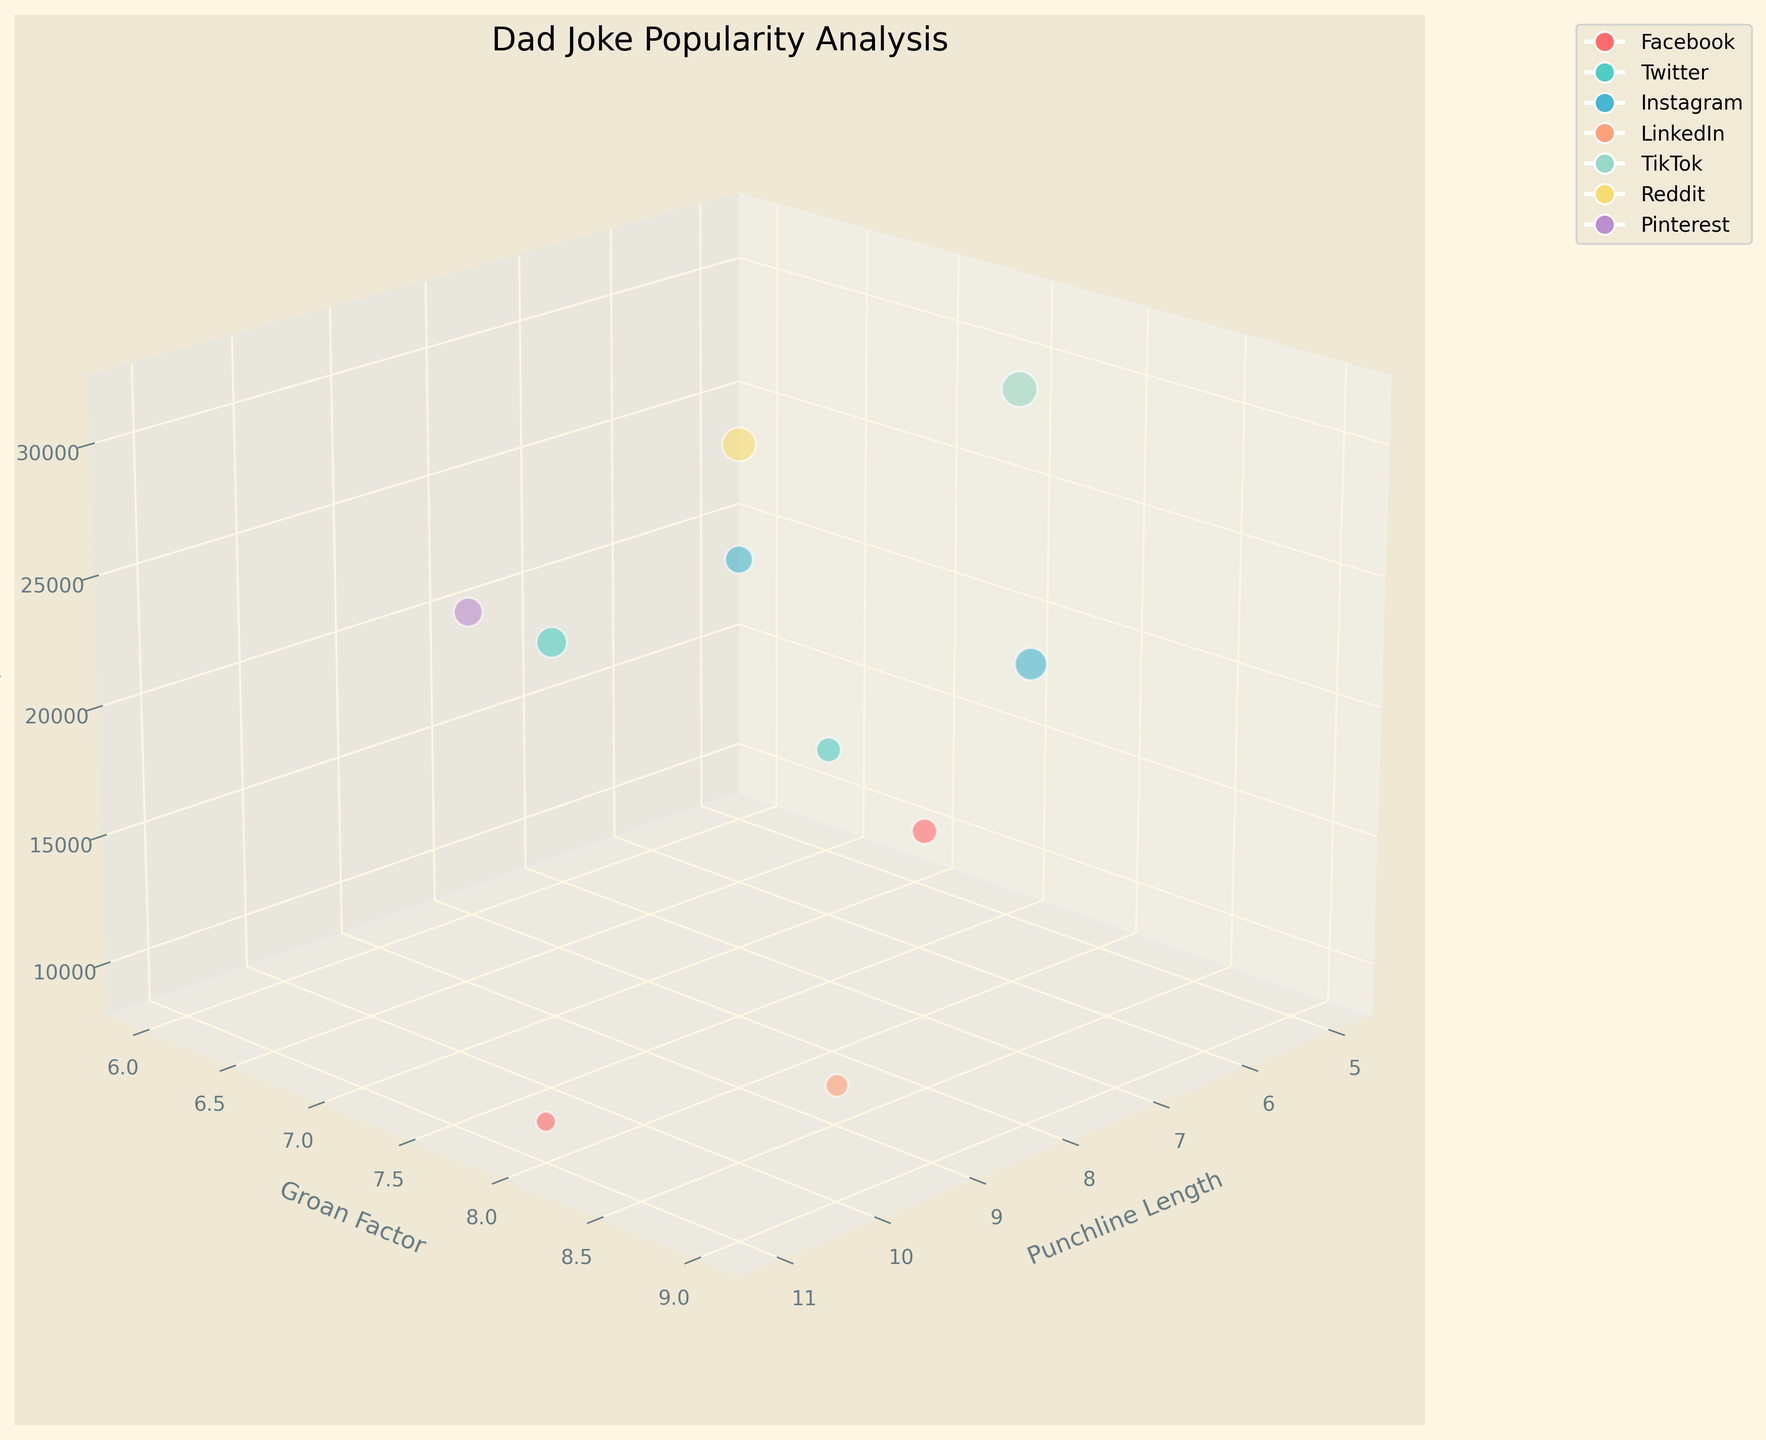How many social media platforms are represented in the chart? We start by examining the legend or checking the number of different colors in the plot. Each color represents a unique platform. By counting them, we see there are six platforms: Facebook, Twitter, Instagram, LinkedIn, TikTok, and Reddit.
Answer: 6 Which axis represents the punchline length of the jokes? By looking at the axis labels, we can identify which axis corresponds to punchline length. The label of the x-axis reads "Punchline Length."
Answer: x-axis Which joke has received the highest number of shares? We look for the bubble with the largest size in the chart since bubble size is proportional to the number of shares. By checking the legends and data points, we find that the joke "How do you organize a space party? You planet!" from TikTok has the highest number of shares at 31,000.
Answer: “How do you organize a space party? You planet!” Which platform has the joke with the longest punchline length? We identify the joke with the highest x-axis (punchline length) value and note its color. The longest punchline is 11, which matches the color representing Facebook.
Answer: Facebook What is the average groan factor of the jokes across all platforms? The groan factors are 8, 7, 6, 9, 8, 7, 6, 8, 7, and 9. Adding these together gives 75. Dividing by the number of jokes (10) results in an average of 7.5
Answer: 7.5 Which joke on LinkedIn received the lowest number of shares? By looking at the data for LinkedIn jokes, we see there is only one represented. It is the joke "Why did the scarecrow win an award?" with 12,300 shares, which is consequently the lowest.
Answer: "Why did the scarecrow win an award?" Is there a relationship between groan factor and the number of shares? Analyzing the z-axis for shares and the y-axis for groan factor, we observe that jokes with higher groan factors like 8 or 9 tend to also have higher shares. However, this is not always the case, indicating a weak positive trend.
Answer: Weak positive trend Which jokes have the same groan factor but are from different platforms? We compare jokes with identical y-axis (groan factor) values. For example, both "What do you call a bear with no teeth?" from Pinterest and "What do you call a fake noodle?" from Instagram have a groan factor of 6.
Answer: "What do you call a fake noodle?" and "What do you call a bear with no teeth?" 